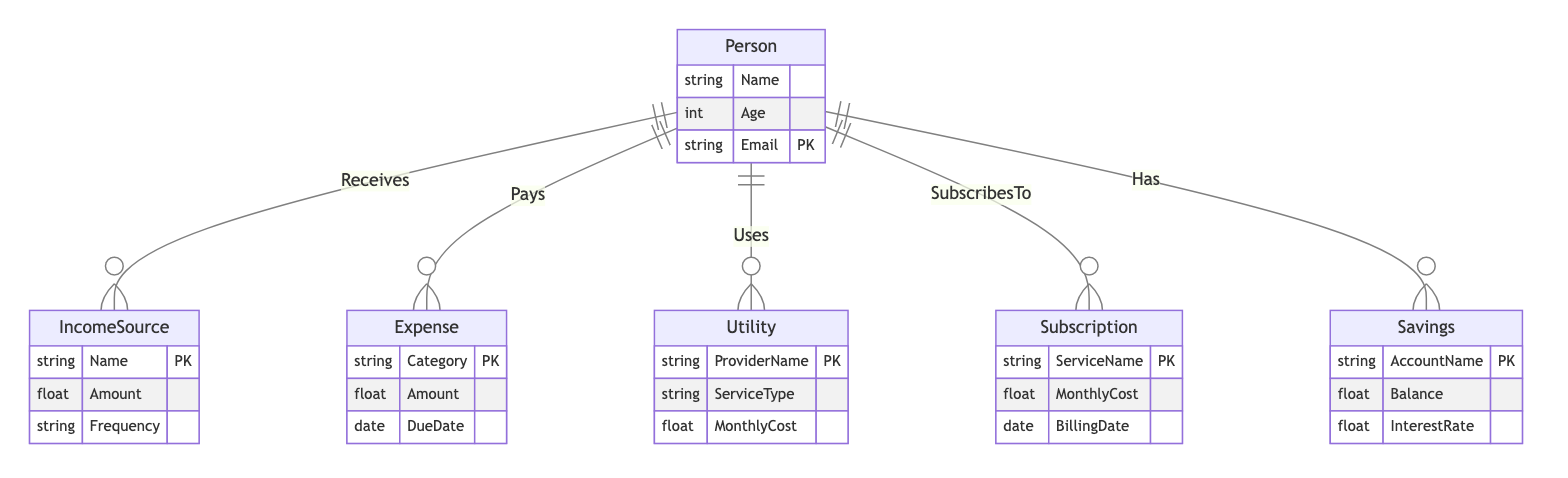What entities are present in the diagram? The diagram contains six entities: Person, IncomeSource, Expense, Utility, Subscription, and Savings. Each entity represents a different aspect of a household budget.
Answer: Person, IncomeSource, Expense, Utility, Subscription, Savings How many income sources can a person have? The relationship "Receives" indicates a "1:N" cardinality, which means one person can have multiple income sources.
Answer: N What is the primary key for the Expense entity? The primary key is designated as "Category," indicating that each expense must have a unique category name.
Answer: Category Which entity details monthly costs associated with services? The Utility entity details monthly costs associated with utilities such as electricity or water, as it includes the attribute "MonthlyCost."
Answer: Utility How does a person interact with their savings? The relationship "Has" shows that a person can have multiple savings accounts, each linked to the person in the diagram.
Answer: Has What attributes are associated with the Subscription entity? The Subscription entity includes the attributes ServiceName, MonthlyCost, and BillingDate, describing the details of various subscriptions.
Answer: ServiceName, MonthlyCost, BillingDate How many subscriptions can a person have? The "SubscribesTo" relationship shows a "1:N" cardinality, indicating that a person can have multiple subscriptions.
Answer: N What indicates that expenses are associated with specific due dates? The Expense entity has a "DueDate" attribute, which denotes that each expense is linked to a particular payment deadline.
Answer: DueDate Which relationship shows how a person pays for expenses? The "Pays" relationship outlines how a person is linked to their various expenses, indicating their payment obligations.
Answer: Pays 